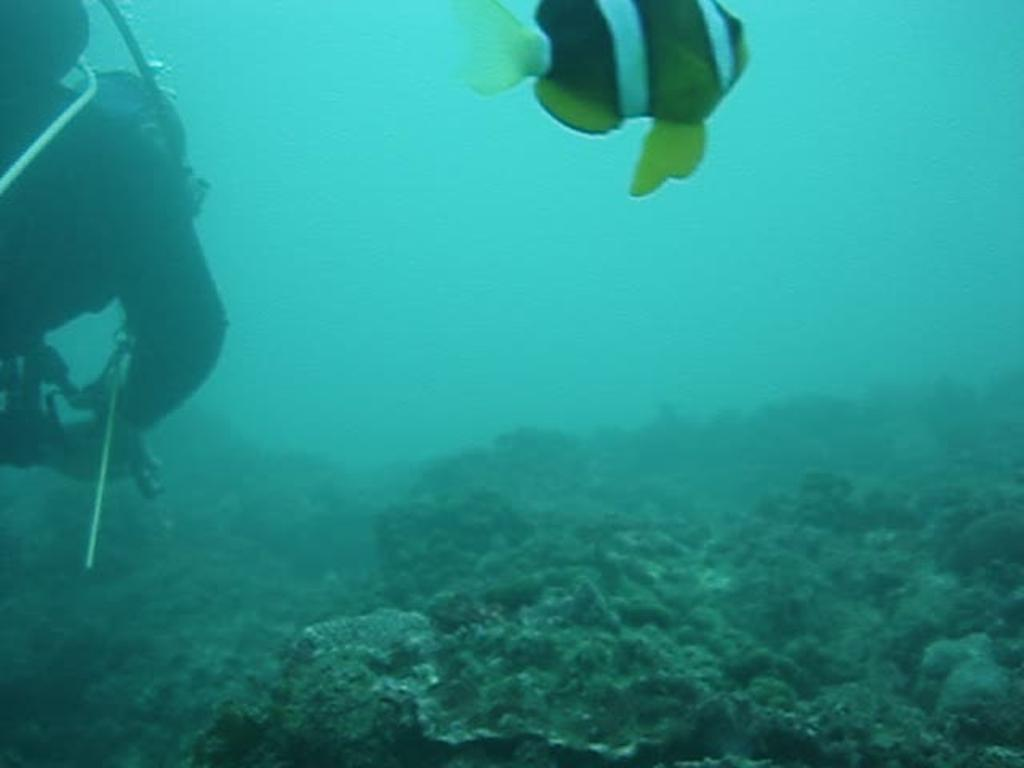What type of animal is in the image? There is a fish in the image. What other objects can be seen in the image? There are submarine plants and an oxygen cylinder visible in the image. Is there a person present in the image? Yes, there is a person in the image. Where might this image have been taken? The image is likely taken in the sea, given the presence of submarine plants and a fish. What type of drawer can be seen in the image? There is no drawer present in the image. What border is visible in the image? There is no border visible in the image. 